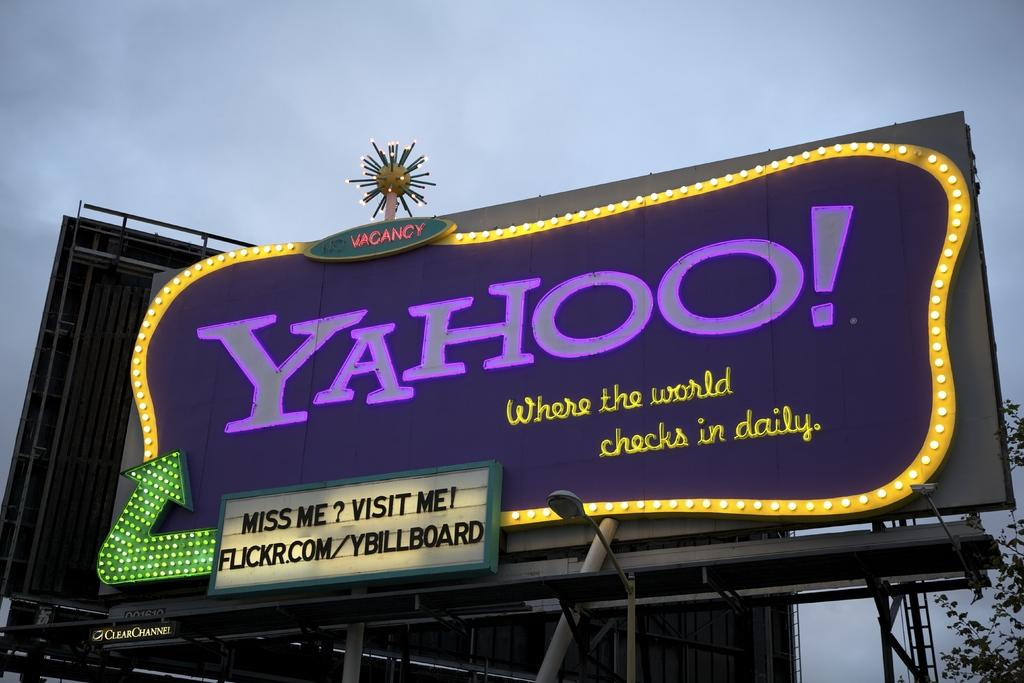<image>
Summarize the visual content of the image. A billboard for Yahoo shows a website address on it. 